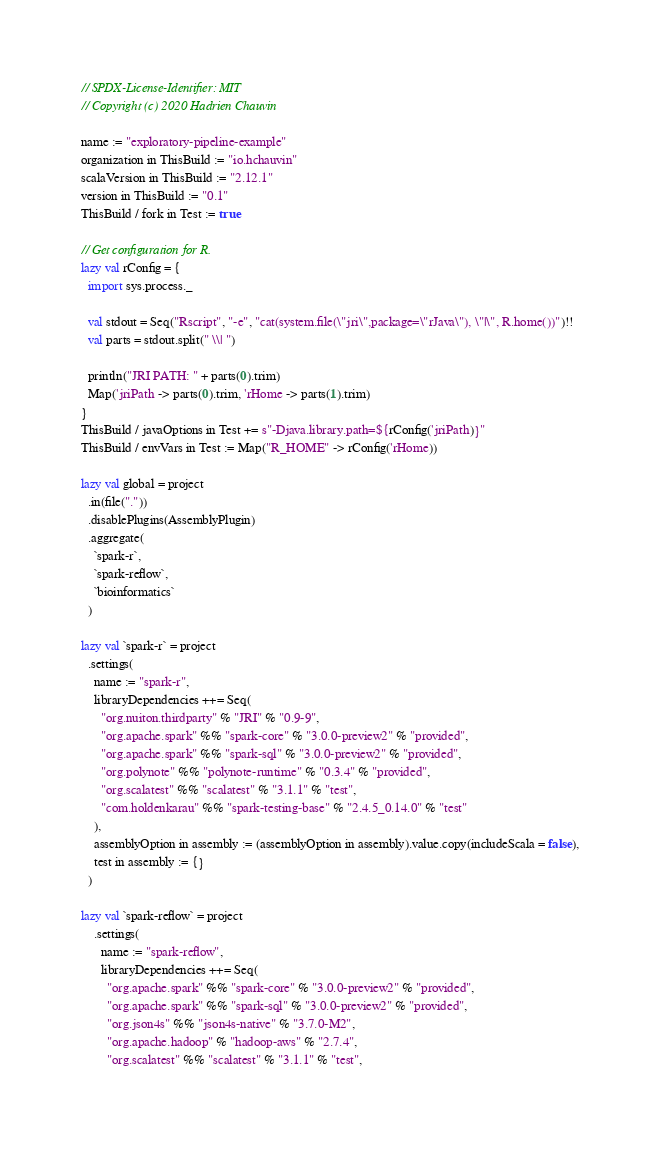<code> <loc_0><loc_0><loc_500><loc_500><_Scala_>// SPDX-License-Identifier: MIT
// Copyright (c) 2020 Hadrien Chauvin

name := "exploratory-pipeline-example"
organization in ThisBuild := "io.hchauvin"
scalaVersion in ThisBuild := "2.12.1"
version in ThisBuild := "0.1"
ThisBuild / fork in Test := true

// Get configuration for R.
lazy val rConfig = {
  import sys.process._

  val stdout = Seq("Rscript", "-e", "cat(system.file(\"jri\",package=\"rJava\"), \"|\", R.home())")!!
  val parts = stdout.split(" \\| ")

  println("JRI PATH: " + parts(0).trim)
  Map('jriPath -> parts(0).trim, 'rHome -> parts(1).trim)
}
ThisBuild / javaOptions in Test += s"-Djava.library.path=${rConfig('jriPath)}"
ThisBuild / envVars in Test := Map("R_HOME" -> rConfig('rHome))

lazy val global = project
  .in(file("."))
  .disablePlugins(AssemblyPlugin)
  .aggregate(
    `spark-r`,
    `spark-reflow`,
    `bioinformatics`
  )

lazy val `spark-r` = project
  .settings(
    name := "spark-r",
    libraryDependencies ++= Seq(
      "org.nuiton.thirdparty" % "JRI" % "0.9-9",
      "org.apache.spark" %% "spark-core" % "3.0.0-preview2" % "provided",
      "org.apache.spark" %% "spark-sql" % "3.0.0-preview2" % "provided",
      "org.polynote" %% "polynote-runtime" % "0.3.4" % "provided",
      "org.scalatest" %% "scalatest" % "3.1.1" % "test",
      "com.holdenkarau" %% "spark-testing-base" % "2.4.5_0.14.0" % "test"
    ),
    assemblyOption in assembly := (assemblyOption in assembly).value.copy(includeScala = false),
    test in assembly := {}
  )

lazy val `spark-reflow` = project
    .settings(
      name := "spark-reflow",
      libraryDependencies ++= Seq(
        "org.apache.spark" %% "spark-core" % "3.0.0-preview2" % "provided",
        "org.apache.spark" %% "spark-sql" % "3.0.0-preview2" % "provided",
        "org.json4s" %% "json4s-native" % "3.7.0-M2",
        "org.apache.hadoop" % "hadoop-aws" % "2.7.4",
        "org.scalatest" %% "scalatest" % "3.1.1" % "test",</code> 